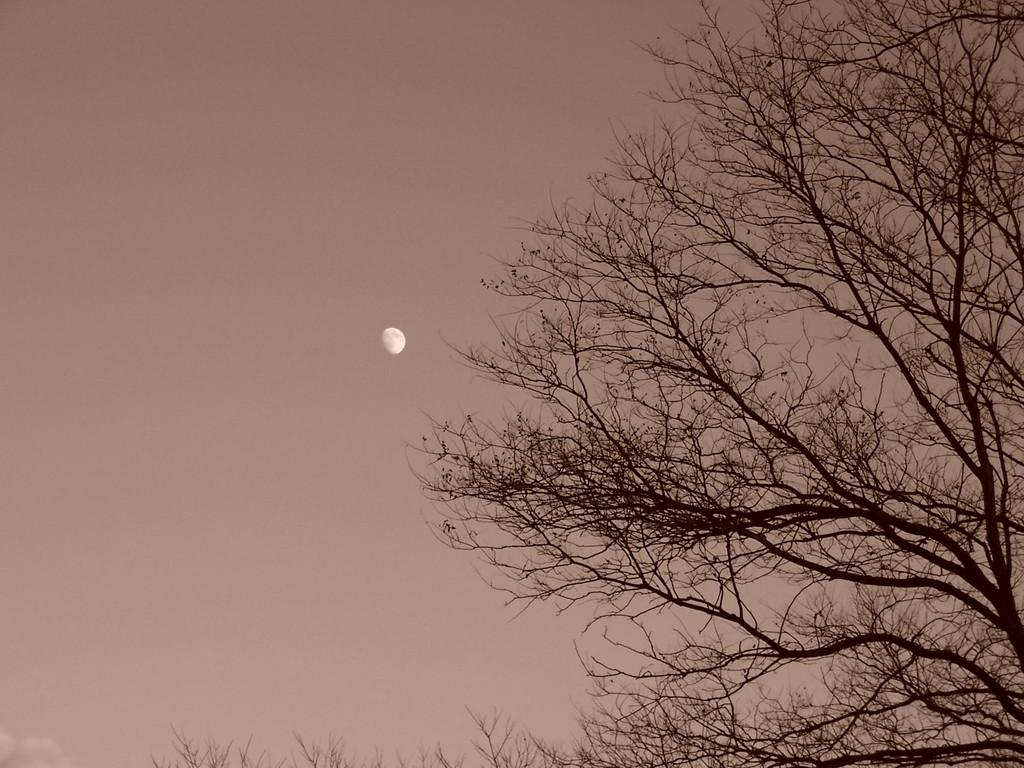What type of vegetation is on the right side of the image? There are trees on the right side of the image. What is visible in the background of the image? The background of the image includes the sky. What celestial body can be seen in the sky in the image? The sky has the moon visible in it. What type of twist can be seen in the design of the mask in the image? There is no mask or design present in the image; it features trees and the sky with the moon visible. 